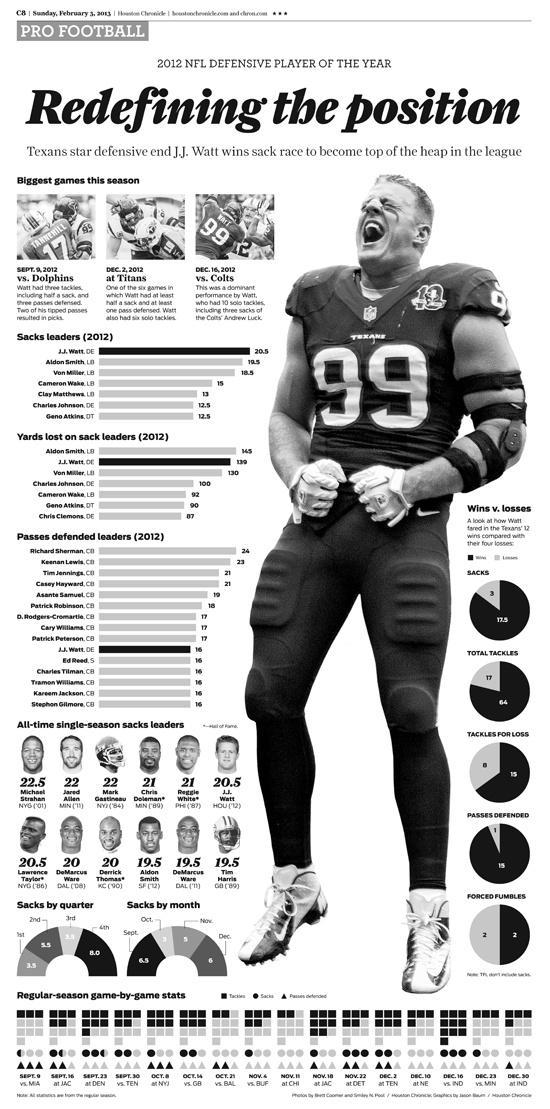Against which team Matt had the match on December 16, 2012?
Answer the question with a short phrase. Colts Who is second highest among sack leaders 2012? Aldon Smith Who has defended the second highest no of passes in 2012? Keenan Lewis How many passes were defended in the game on November 22 at DET? 2 What is the percentage of wins of Matt in total tackles? 64 How many tackles was there on the game of September 16 at JAC? 5 In which position J.J Watt used to play? defensive end What is the no of sacks in the game on November 22 at DET? 3 Who has defended the fourth highest no of passes in 2012? Asante Samuel What is the percentage of wins of Matt in sacks? 17.5 